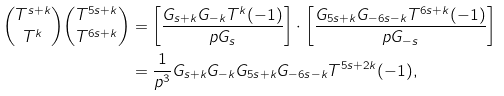Convert formula to latex. <formula><loc_0><loc_0><loc_500><loc_500>\binom { T ^ { s + k } } { T ^ { k } } \binom { T ^ { 5 s + k } } { T ^ { 6 s + k } } & = \left [ \frac { G _ { s + k } G _ { - k } T ^ { k } ( - 1 ) } { p G _ { s } } \right ] \cdot \left [ \frac { G _ { 5 s + k } G _ { - 6 s - k } T ^ { 6 s + k } ( - 1 ) } { p G _ { - s } } \right ] \\ & = \frac { 1 } { p ^ { 3 } } G _ { s + k } G _ { - k } G _ { 5 s + k } G _ { - 6 s - k } T ^ { 5 s + 2 k } ( - 1 ) ,</formula> 